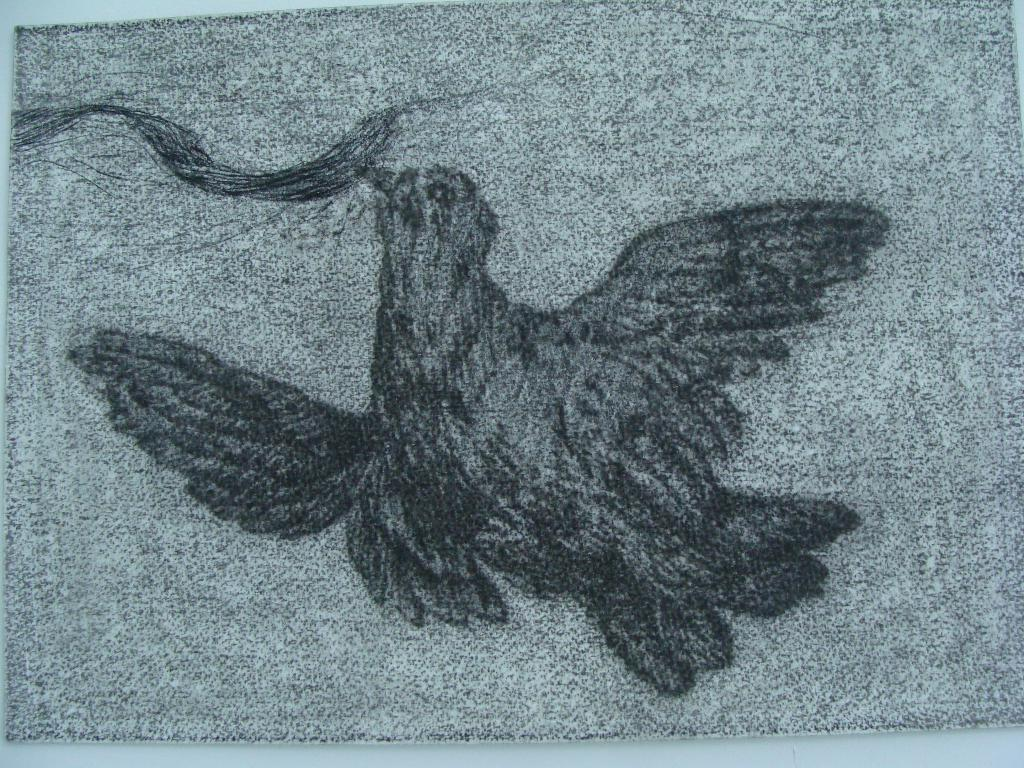What is depicted in the image? There is a sketch art of a bird in the image. What is the background of the sketch art? The sketch art is placed on a white surface. What type of crate is visible in the image? There is no crate present in the image. What is the bird's destination in the image? The image is a sketch art of a bird, and there is no indication of a destination or voyage. 